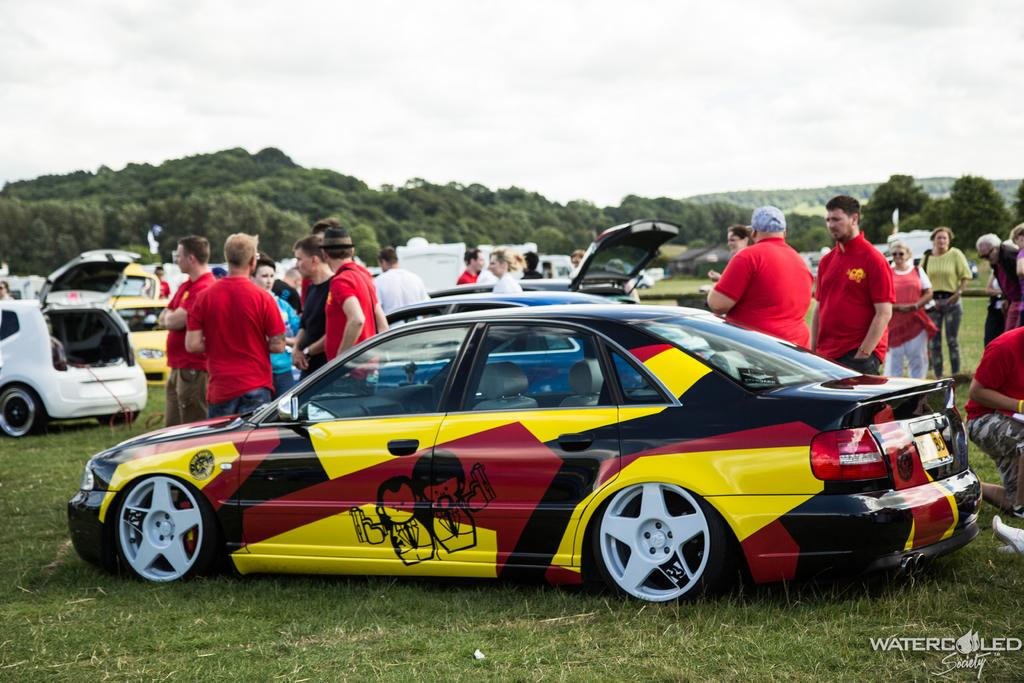What are the people in the image doing? There is a group of people standing in the image. What can be seen in the background of the image? There are cars parked, grass, and trees visible in the image. Is there any indication of the image's origin or ownership? Yes, there is a watermark on the image. How many pears are being used as a bomb in the image? There are no pears or bombs present in the image. Are there any children visible in the image? The provided facts do not mention children, so we cannot determine if they are present in the image. 